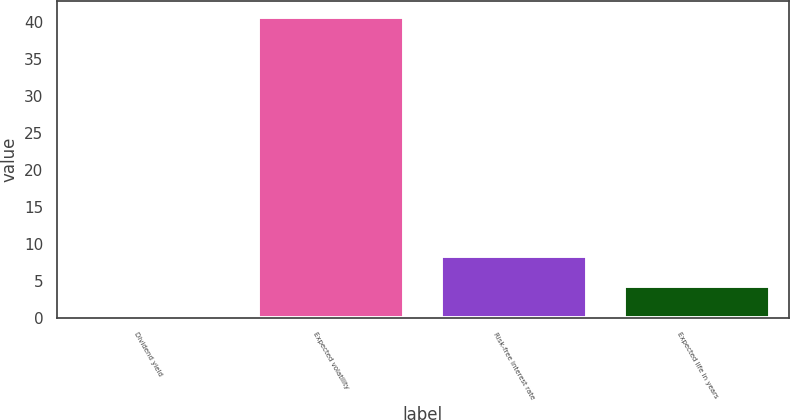Convert chart. <chart><loc_0><loc_0><loc_500><loc_500><bar_chart><fcel>Dividend yield<fcel>Expected volatility<fcel>Risk-free interest rate<fcel>Expected life in years<nl><fcel>0.3<fcel>40.8<fcel>8.4<fcel>4.35<nl></chart> 